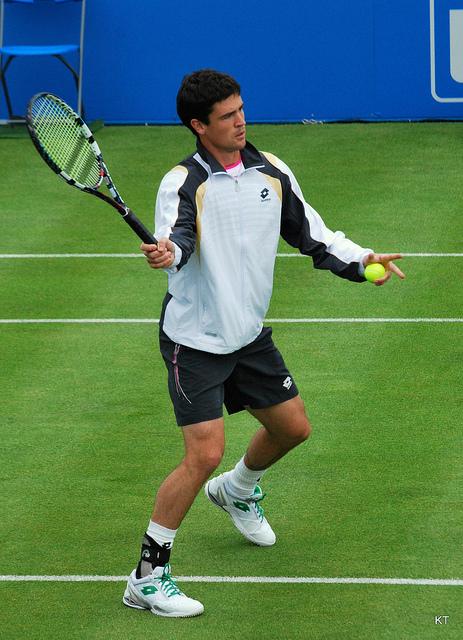What is on the man's feet?
Keep it brief. Tennis shoes. Which foot is not completely on the ground?
Answer briefly. Left. Is the warming up for the match?
Answer briefly. Yes. 